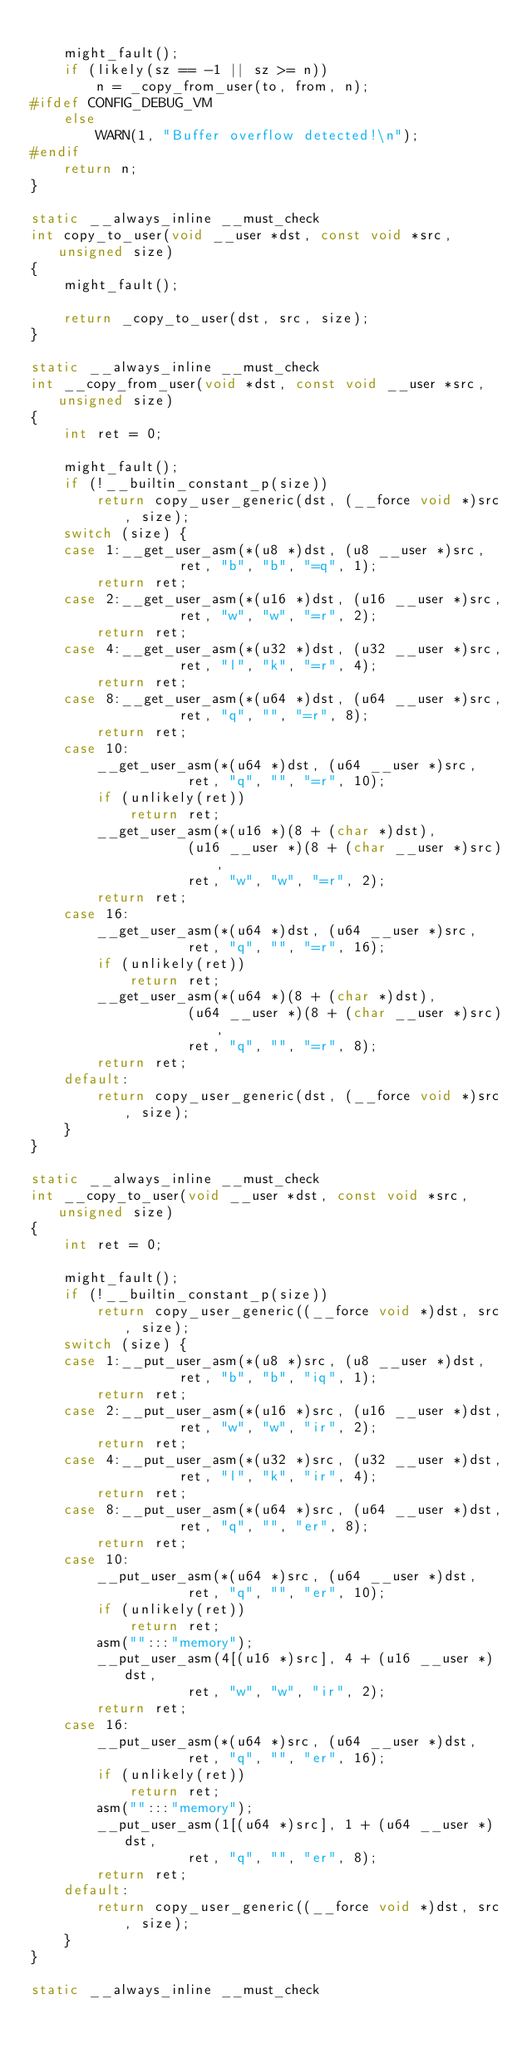<code> <loc_0><loc_0><loc_500><loc_500><_C_>
	might_fault();
	if (likely(sz == -1 || sz >= n))
		n = _copy_from_user(to, from, n);
#ifdef CONFIG_DEBUG_VM
	else
		WARN(1, "Buffer overflow detected!\n");
#endif
	return n;
}

static __always_inline __must_check
int copy_to_user(void __user *dst, const void *src, unsigned size)
{
	might_fault();

	return _copy_to_user(dst, src, size);
}

static __always_inline __must_check
int __copy_from_user(void *dst, const void __user *src, unsigned size)
{
	int ret = 0;

	might_fault();
	if (!__builtin_constant_p(size))
		return copy_user_generic(dst, (__force void *)src, size);
	switch (size) {
	case 1:__get_user_asm(*(u8 *)dst, (u8 __user *)src,
			      ret, "b", "b", "=q", 1);
		return ret;
	case 2:__get_user_asm(*(u16 *)dst, (u16 __user *)src,
			      ret, "w", "w", "=r", 2);
		return ret;
	case 4:__get_user_asm(*(u32 *)dst, (u32 __user *)src,
			      ret, "l", "k", "=r", 4);
		return ret;
	case 8:__get_user_asm(*(u64 *)dst, (u64 __user *)src,
			      ret, "q", "", "=r", 8);
		return ret;
	case 10:
		__get_user_asm(*(u64 *)dst, (u64 __user *)src,
			       ret, "q", "", "=r", 10);
		if (unlikely(ret))
			return ret;
		__get_user_asm(*(u16 *)(8 + (char *)dst),
			       (u16 __user *)(8 + (char __user *)src),
			       ret, "w", "w", "=r", 2);
		return ret;
	case 16:
		__get_user_asm(*(u64 *)dst, (u64 __user *)src,
			       ret, "q", "", "=r", 16);
		if (unlikely(ret))
			return ret;
		__get_user_asm(*(u64 *)(8 + (char *)dst),
			       (u64 __user *)(8 + (char __user *)src),
			       ret, "q", "", "=r", 8);
		return ret;
	default:
		return copy_user_generic(dst, (__force void *)src, size);
	}
}

static __always_inline __must_check
int __copy_to_user(void __user *dst, const void *src, unsigned size)
{
	int ret = 0;

	might_fault();
	if (!__builtin_constant_p(size))
		return copy_user_generic((__force void *)dst, src, size);
	switch (size) {
	case 1:__put_user_asm(*(u8 *)src, (u8 __user *)dst,
			      ret, "b", "b", "iq", 1);
		return ret;
	case 2:__put_user_asm(*(u16 *)src, (u16 __user *)dst,
			      ret, "w", "w", "ir", 2);
		return ret;
	case 4:__put_user_asm(*(u32 *)src, (u32 __user *)dst,
			      ret, "l", "k", "ir", 4);
		return ret;
	case 8:__put_user_asm(*(u64 *)src, (u64 __user *)dst,
			      ret, "q", "", "er", 8);
		return ret;
	case 10:
		__put_user_asm(*(u64 *)src, (u64 __user *)dst,
			       ret, "q", "", "er", 10);
		if (unlikely(ret))
			return ret;
		asm("":::"memory");
		__put_user_asm(4[(u16 *)src], 4 + (u16 __user *)dst,
			       ret, "w", "w", "ir", 2);
		return ret;
	case 16:
		__put_user_asm(*(u64 *)src, (u64 __user *)dst,
			       ret, "q", "", "er", 16);
		if (unlikely(ret))
			return ret;
		asm("":::"memory");
		__put_user_asm(1[(u64 *)src], 1 + (u64 __user *)dst,
			       ret, "q", "", "er", 8);
		return ret;
	default:
		return copy_user_generic((__force void *)dst, src, size);
	}
}

static __always_inline __must_check</code> 